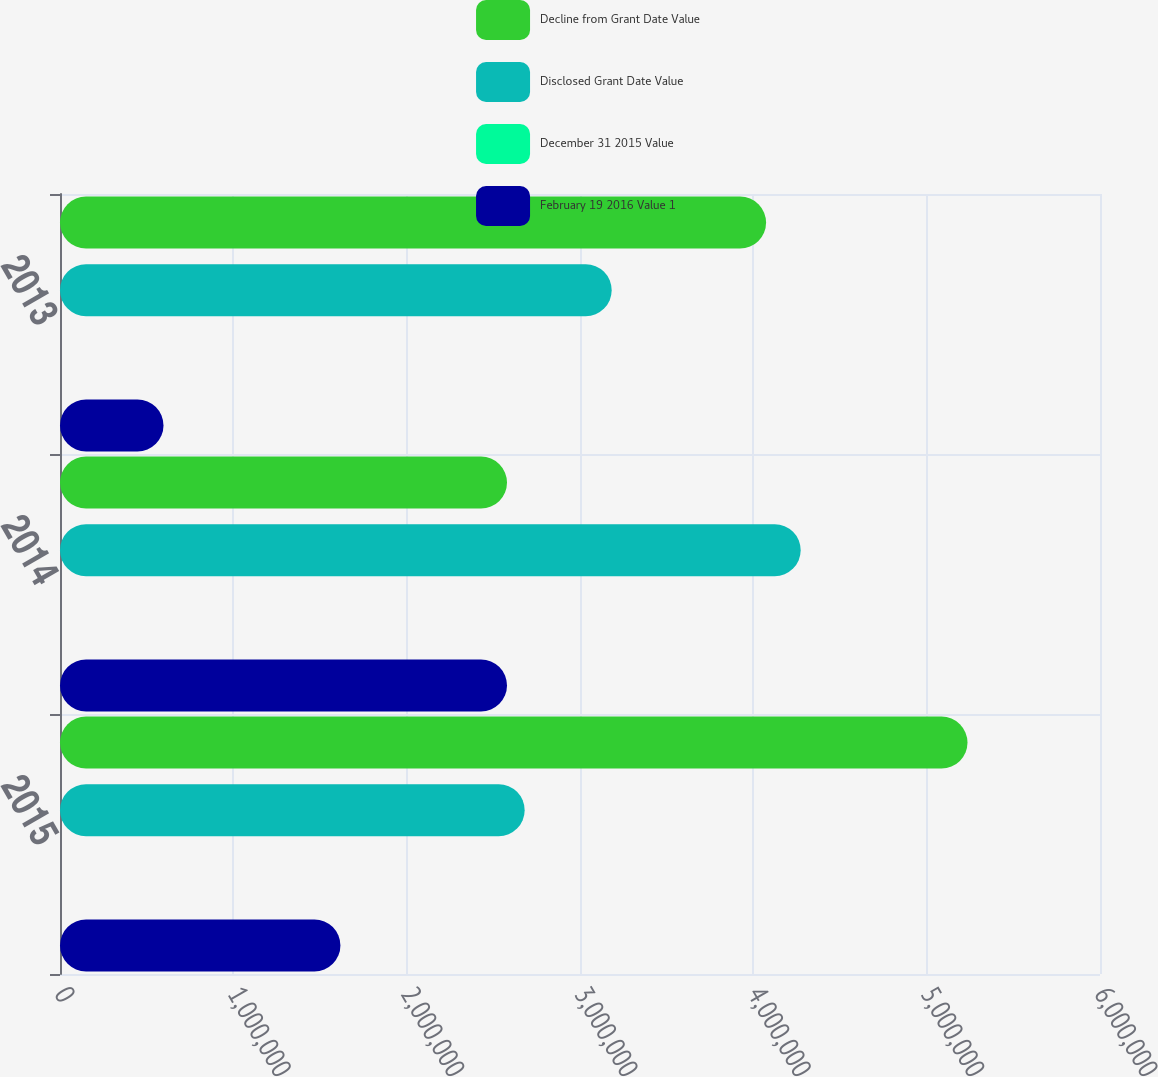Convert chart. <chart><loc_0><loc_0><loc_500><loc_500><stacked_bar_chart><ecel><fcel>2015<fcel>2014<fcel>2013<nl><fcel>Decline from Grant Date Value<fcel>5.23556e+06<fcel>2.57885e+06<fcel>4.07362e+06<nl><fcel>Disclosed Grant Date Value<fcel>2.68072e+06<fcel>4.27314e+06<fcel>3.18276e+06<nl><fcel>December 31 2015 Value<fcel>49<fcel>48<fcel>22<nl><fcel>February 19 2016 Value 1<fcel>1.61782e+06<fcel>2.57885e+06<fcel>597089<nl></chart> 